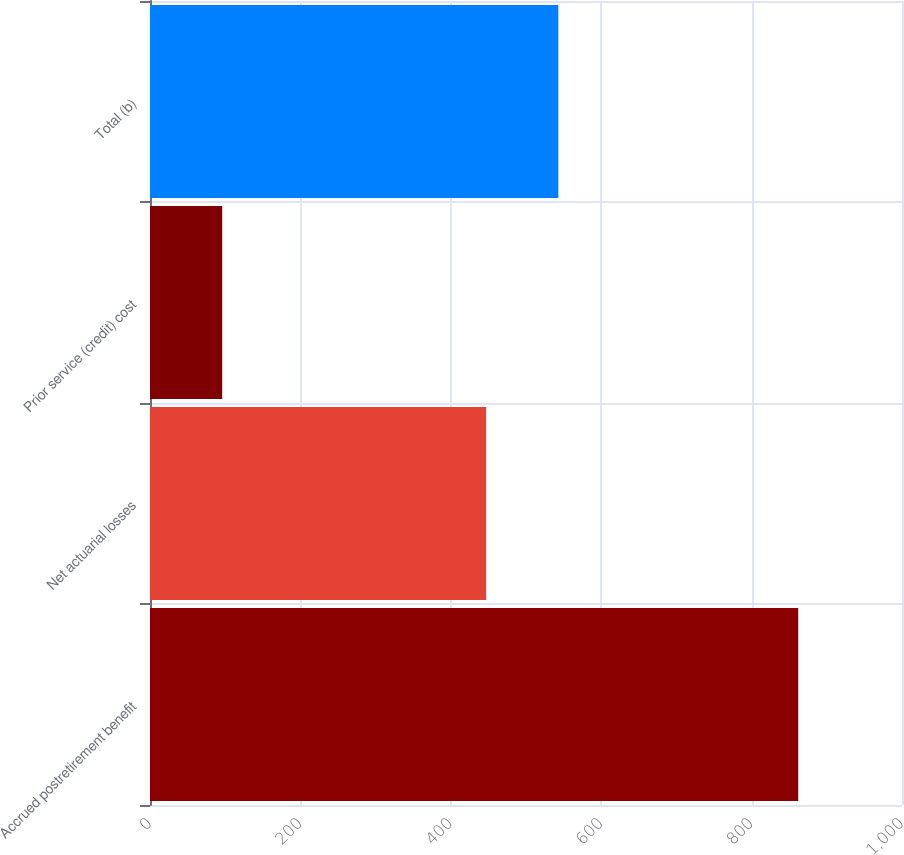Convert chart to OTSL. <chart><loc_0><loc_0><loc_500><loc_500><bar_chart><fcel>Accrued postretirement benefit<fcel>Net actuarial losses<fcel>Prior service (credit) cost<fcel>Total (b)<nl><fcel>862<fcel>447<fcel>96<fcel>543<nl></chart> 